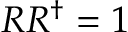Convert formula to latex. <formula><loc_0><loc_0><loc_500><loc_500>R R ^ { \dagger } = 1</formula> 